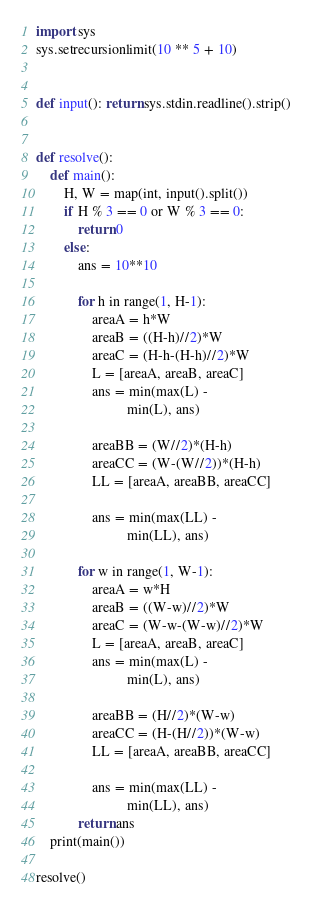<code> <loc_0><loc_0><loc_500><loc_500><_Python_>import sys
sys.setrecursionlimit(10 ** 5 + 10)


def input(): return sys.stdin.readline().strip()


def resolve():
    def main():
        H, W = map(int, input().split())
        if H % 3 == 0 or W % 3 == 0:
            return 0
        else:
            ans = 10**10

            for h in range(1, H-1):
                areaA = h*W
                areaB = ((H-h)//2)*W
                areaC = (H-h-(H-h)//2)*W
                L = [areaA, areaB, areaC]
                ans = min(max(L) -
                          min(L), ans)

                areaBB = (W//2)*(H-h)
                areaCC = (W-(W//2))*(H-h)
                LL = [areaA, areaBB, areaCC]

                ans = min(max(LL) -
                          min(LL), ans)

            for w in range(1, W-1):
                areaA = w*H
                areaB = ((W-w)//2)*W
                areaC = (W-w-(W-w)//2)*W
                L = [areaA, areaB, areaC]
                ans = min(max(L) -
                          min(L), ans)

                areaBB = (H//2)*(W-w)
                areaCC = (H-(H//2))*(W-w)
                LL = [areaA, areaBB, areaCC]

                ans = min(max(LL) -
                          min(LL), ans)
            return ans
    print(main())

resolve()</code> 